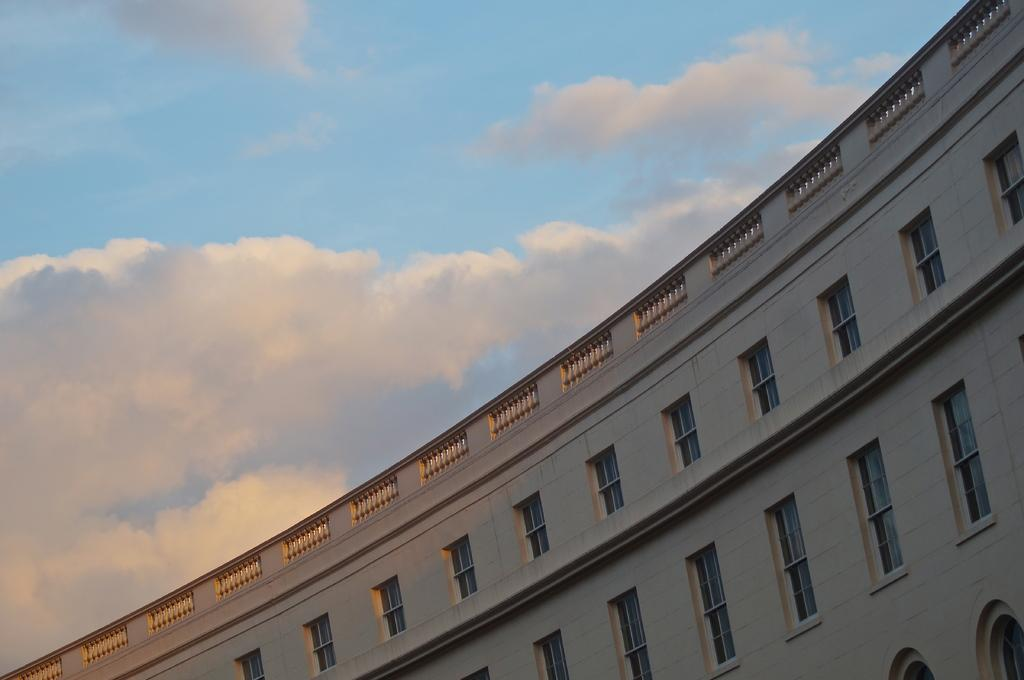What is the main structure in the image? There is a building in the image. What feature can be seen on the building? The building has windows. What is visible in the background of the image? The sky is visible in the image. What can be observed in the sky? There are clouds in the sky. What type of stitch is being used to hold the clouds together in the image? There is no stitching present in the image; the clouds are naturally occurring in the sky. 